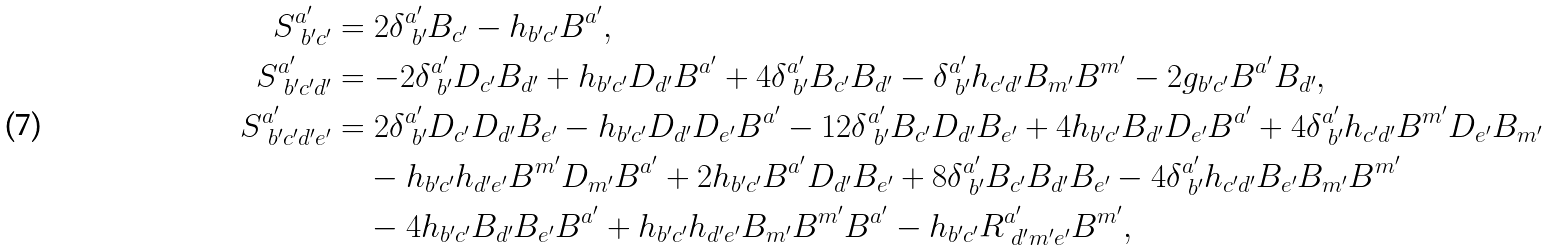<formula> <loc_0><loc_0><loc_500><loc_500>S ^ { a ^ { \prime } } _ { \ b ^ { \prime } c ^ { \prime } } & = 2 \delta ^ { a ^ { \prime } } _ { \ b ^ { \prime } } B _ { c ^ { \prime } } - h _ { b ^ { \prime } c ^ { \prime } } B ^ { a ^ { \prime } } , \\ S ^ { a ^ { \prime } } _ { \ b ^ { \prime } c ^ { \prime } d ^ { \prime } } & = - 2 \delta ^ { a ^ { \prime } } _ { \ b ^ { \prime } } D _ { c ^ { \prime } } B _ { d ^ { \prime } } + h _ { b ^ { \prime } c ^ { \prime } } D _ { d ^ { \prime } } B ^ { a ^ { \prime } } + 4 \delta ^ { a ^ { \prime } } _ { \ b ^ { \prime } } B _ { c ^ { \prime } } B _ { d ^ { \prime } } - \delta ^ { a ^ { \prime } } _ { \ b ^ { \prime } } h _ { c ^ { \prime } d ^ { \prime } } B _ { m ^ { \prime } } B ^ { m ^ { \prime } } - 2 g _ { b ^ { \prime } c ^ { \prime } } B ^ { a ^ { \prime } } B _ { d ^ { \prime } } , \\ S ^ { a ^ { \prime } } _ { \ b ^ { \prime } c ^ { \prime } d ^ { \prime } e ^ { \prime } } & = 2 \delta ^ { a ^ { \prime } } _ { \ b ^ { \prime } } D _ { c ^ { \prime } } D _ { d ^ { \prime } } B _ { e ^ { \prime } } - h _ { b ^ { \prime } c ^ { \prime } } D _ { d ^ { \prime } } D _ { e ^ { \prime } } B ^ { a ^ { \prime } } - 1 2 \delta ^ { a ^ { \prime } } _ { \ b ^ { \prime } } B _ { c ^ { \prime } } D _ { d ^ { \prime } } B _ { e ^ { \prime } } + 4 h _ { b ^ { \prime } c ^ { \prime } } B _ { d ^ { \prime } } D _ { e ^ { \prime } } B ^ { a ^ { \prime } } + 4 \delta ^ { a ^ { \prime } } _ { \ b ^ { \prime } } h _ { c ^ { \prime } d ^ { \prime } } B ^ { m ^ { \prime } } D _ { e ^ { \prime } } B _ { m ^ { \prime } } \\ & \quad - h _ { b ^ { \prime } c ^ { \prime } } h _ { d ^ { \prime } e ^ { \prime } } B ^ { m ^ { \prime } } D _ { m ^ { \prime } } B ^ { a ^ { \prime } } + 2 h _ { b ^ { \prime } c ^ { \prime } } B ^ { a ^ { \prime } } D _ { d ^ { \prime } } B _ { e ^ { \prime } } + 8 \delta ^ { a ^ { \prime } } _ { \ b ^ { \prime } } B _ { c ^ { \prime } } B _ { d ^ { \prime } } B _ { e ^ { \prime } } - 4 \delta ^ { a ^ { \prime } } _ { \ b ^ { \prime } } h _ { c ^ { \prime } d ^ { \prime } } B _ { e ^ { \prime } } B _ { m ^ { \prime } } B ^ { m ^ { \prime } } \\ & \quad - 4 h _ { b ^ { \prime } c ^ { \prime } } B _ { d ^ { \prime } } B _ { e ^ { \prime } } B ^ { a ^ { \prime } } + h _ { b ^ { \prime } c ^ { \prime } } h _ { d ^ { \prime } e ^ { \prime } } B _ { m ^ { \prime } } B ^ { m ^ { \prime } } B ^ { a ^ { \prime } } - h _ { b ^ { \prime } c ^ { \prime } } R ^ { a ^ { \prime } } _ { \ d ^ { \prime } m ^ { \prime } e ^ { \prime } } B ^ { m ^ { \prime } } ,</formula> 